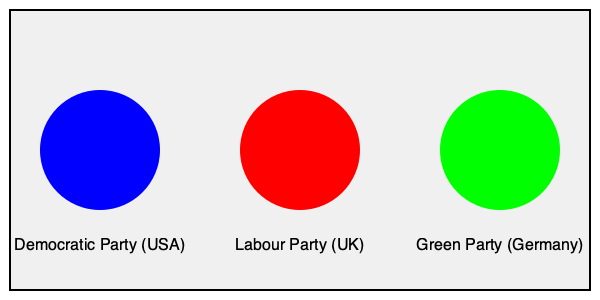Analyze the color symbolism used in the logos of the Democratic Party (USA), Labour Party (UK), and Green Party (Germany). How do these colors relate to each party's ideological positioning and messaging strategies within their respective political landscapes? 1. Democratic Party (USA) - Blue:
   - Blue traditionally symbolizes trust, stability, and calmness.
   - In the US political context, it represents liberalism and progressivism.
   - The choice of blue helps frame the party as reliable and forward-thinking.

2. Labour Party (UK) - Red:
   - Red is associated with passion, energy, and revolution.
   - In political contexts, it often represents left-wing ideologies and workers' movements.
   - The use of red frames the Labour Party as a champion of workers' rights and social justice.

3. Green Party (Germany) - Green:
   - Green symbolizes nature, growth, and environmental consciousness.
   - In politics, it represents environmentalism and sustainable development.
   - The green color frames the party as focused on ecological issues and sustainability.

4. Comparative analysis:
   - Each color choice reflects the party's core values and policy priorities.
   - The colors serve as visual shorthand for the parties' ideological positions.
   - These color associations are often culturally specific and may vary between countries.

5. Framing effects:
   - The consistent use of these colors in party communications reinforces their brand identity.
   - Color symbolism can evoke emotional responses and shape public perceptions of the parties.
   - The colors help frame the parties' messages within their national political contexts.

6. Strategic considerations:
   - Parties may choose colors to differentiate themselves from opponents.
   - Color choices can also reflect historical or cultural associations within each country.
   - The use of color in political branding is a deliberate framing technique to influence voter perceptions.
Answer: The colors symbolize each party's core values and ideological positioning: blue for trust and progressivism (Democrats), red for workers' rights and social justice (Labour), and green for environmentalism (Green Party). These color choices frame the parties' identities and messaging strategies within their respective political landscapes. 